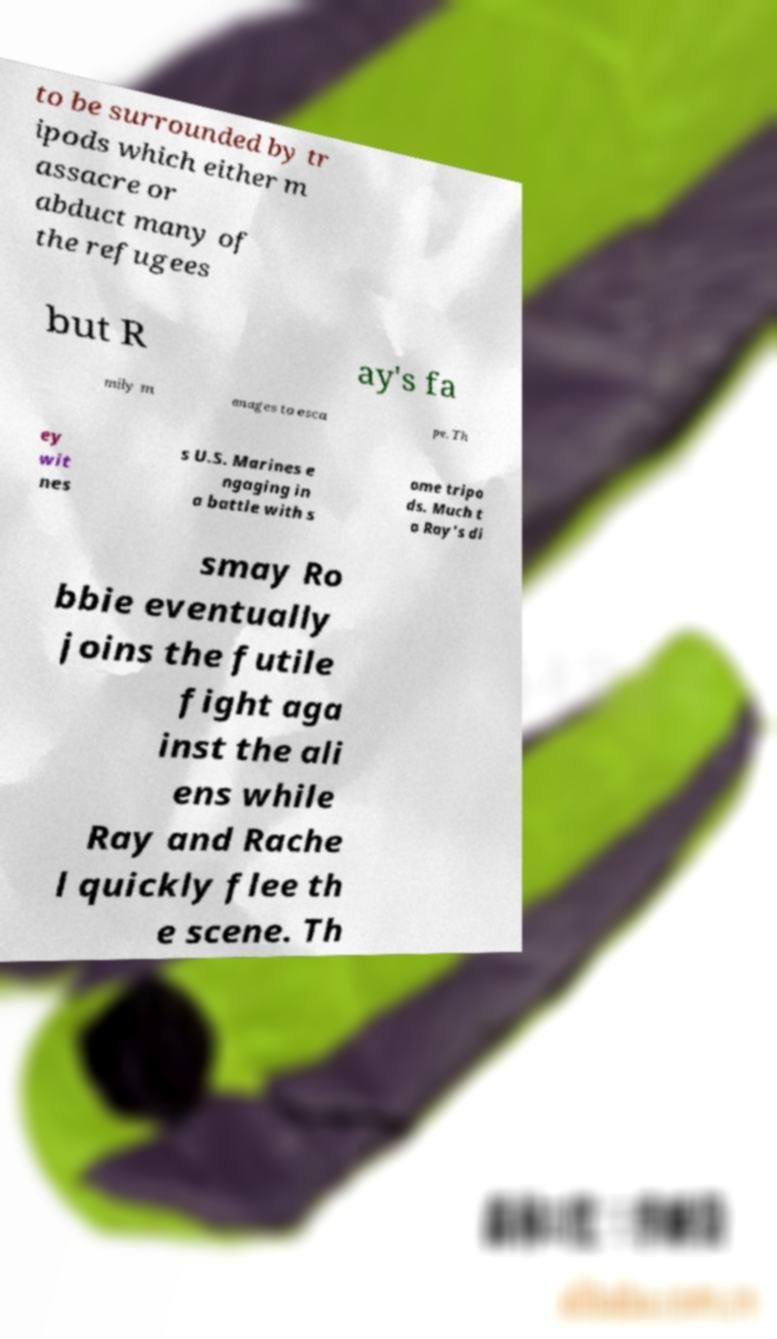I need the written content from this picture converted into text. Can you do that? to be surrounded by tr ipods which either m assacre or abduct many of the refugees but R ay's fa mily m anages to esca pe. Th ey wit nes s U.S. Marines e ngaging in a battle with s ome tripo ds. Much t o Ray's di smay Ro bbie eventually joins the futile fight aga inst the ali ens while Ray and Rache l quickly flee th e scene. Th 